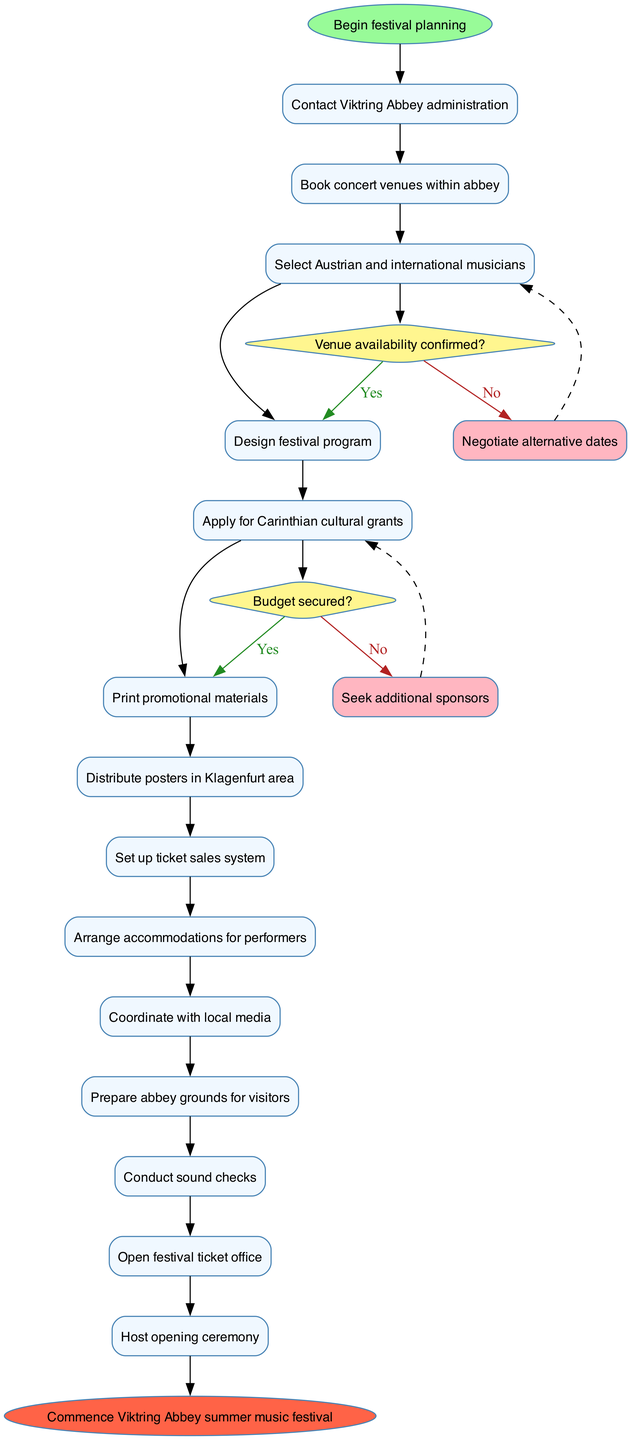What is the initial node of the diagram? The initial node, as specified in the data, is "Begin festival planning." This is the starting point of the activity diagram where the workflow begins.
Answer: Begin festival planning How many activities are listed in the diagram? By counting the entries in the activities section, there are a total of 13 activities that detail the steps involved in organizing the festival.
Answer: 13 What follows after "Book concert venues within abbey"? The subsequent activity after "Book concert venues within abbey" is "Select Austrian and international musicians." This can be identified by the sequential flow of activities in the diagram.
Answer: Select Austrian and international musicians If the budget is not secured, what action is taken next? If the budget is not secured, the next action is to "Seek additional sponsors." This is derived from the decision node that represents this condition in the workflow.
Answer: Seek additional sponsors What is the relationship between "Apply for Carinthian cultural grants" and "Print promotional materials"? The relationship is that "Apply for Carinthian cultural grants" must be completed before proceeding to "Print promotional materials," as these activities are part of the sequential flow indicated in the diagram.
Answer: Sequential flow What happens if the venue availability is confirmed? If venue availability is confirmed, the workflow proceeds to "Proceed with musician selection," as indicated by the 'yes' branch of the decision node related to venue availability.
Answer: Proceed with musician selection Which activity directly precedes the final node? The activity that directly precedes the final node "Commence Viktring Abbey summer music festival" is "Host opening ceremony," marking the final step before the festival commences.
Answer: Host opening ceremony How many decision nodes are present in the diagram? There are two decision nodes in the diagram, which evaluate the conditions regarding venue availability and budget security leading to different paths based on the outcomes.
Answer: 2 What are the two options provided when the decision for venue availability results in 'No'? The two options provided are "Negotiate alternative dates" as an immediate response, represented by the dashed line returning to the previous node, and this option is associated with the necessity of securing venue availability.
Answer: Negotiate alternative dates 